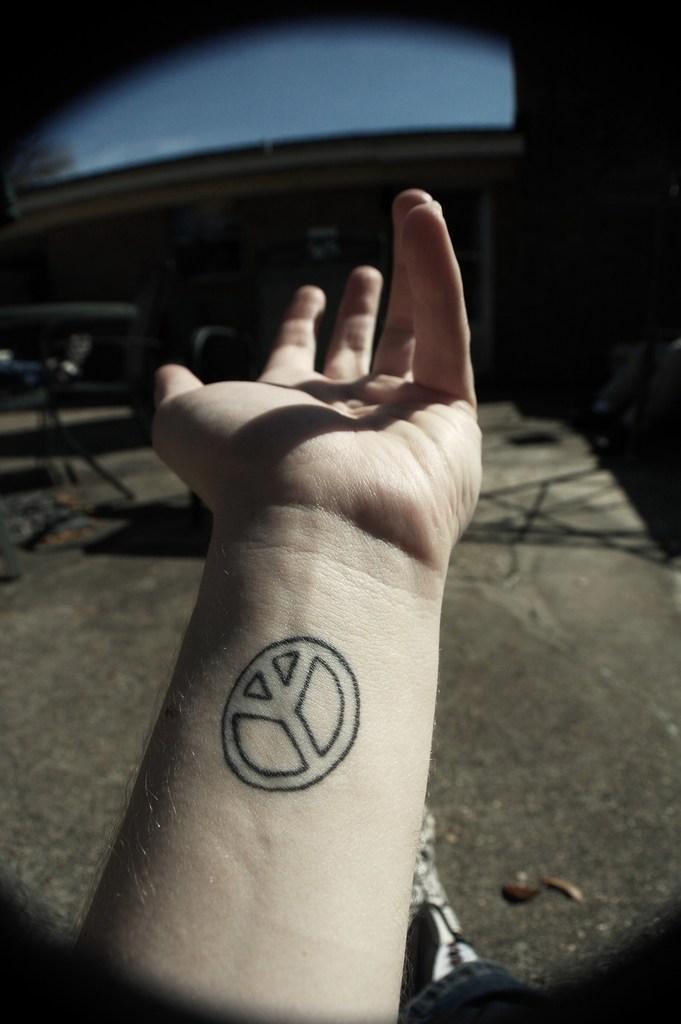Please provide a concise description of this image. In this image we can see a person's hand. On the hand, there is a tattoo. 